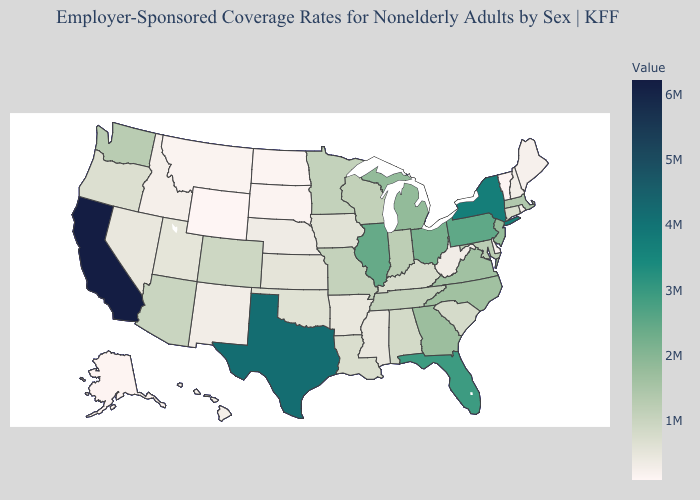Among the states that border Wyoming , does Colorado have the lowest value?
Concise answer only. No. Does Illinois have the highest value in the MidWest?
Concise answer only. Yes. Does New Mexico have the lowest value in the USA?
Answer briefly. No. Does Alabama have the lowest value in the USA?
Be succinct. No. Does Alabama have a higher value than Rhode Island?
Short answer required. Yes. Which states have the lowest value in the USA?
Concise answer only. Wyoming. Does California have the highest value in the USA?
Give a very brief answer. Yes. Does Wyoming have the lowest value in the USA?
Be succinct. Yes. 